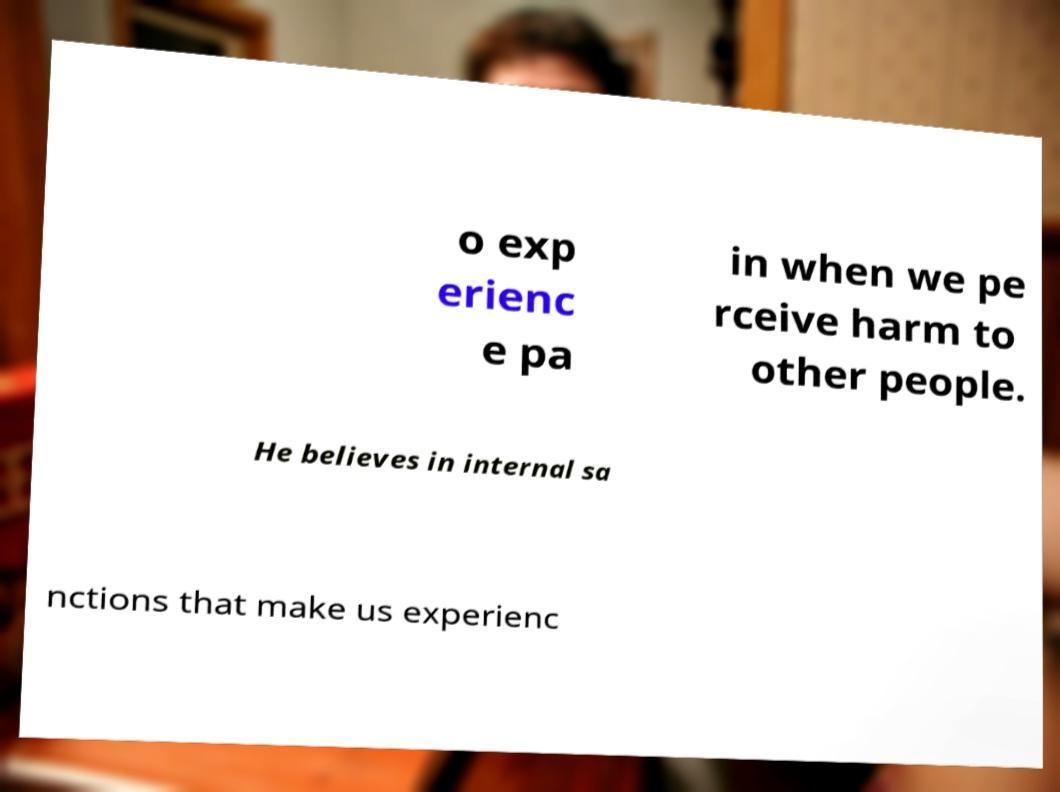What messages or text are displayed in this image? I need them in a readable, typed format. o exp erienc e pa in when we pe rceive harm to other people. He believes in internal sa nctions that make us experienc 